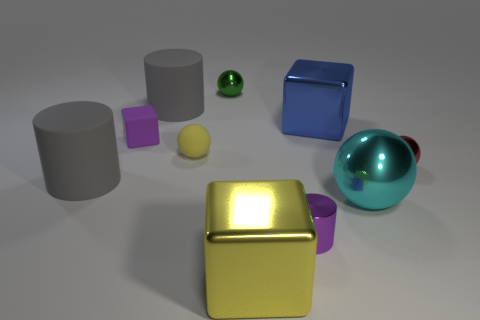Does the small matte block have the same color as the tiny shiny cylinder?
Give a very brief answer. Yes. Is there a object that has the same color as the tiny matte cube?
Your answer should be compact. Yes. How many shiny objects are either yellow spheres or small balls?
Give a very brief answer. 2. How many red spheres are to the left of the large cube in front of the metal cylinder?
Make the answer very short. 0. How many other cylinders have the same material as the small purple cylinder?
Offer a terse response. 0. What number of large objects are shiny spheres or yellow matte objects?
Provide a succinct answer. 1. There is a metallic object that is both behind the large yellow metallic block and on the left side of the small purple cylinder; what is its shape?
Ensure brevity in your answer.  Sphere. Do the yellow cube and the tiny yellow thing have the same material?
Provide a succinct answer. No. What color is the matte sphere that is the same size as the red metal thing?
Your answer should be compact. Yellow. There is a large object that is left of the large yellow object and behind the small yellow object; what color is it?
Provide a succinct answer. Gray. 